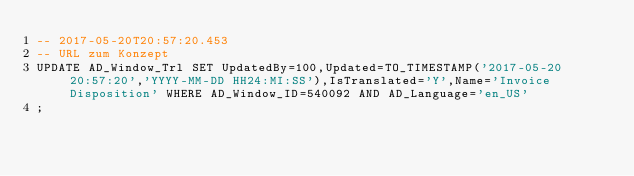<code> <loc_0><loc_0><loc_500><loc_500><_SQL_>-- 2017-05-20T20:57:20.453
-- URL zum Konzept
UPDATE AD_Window_Trl SET UpdatedBy=100,Updated=TO_TIMESTAMP('2017-05-20 20:57:20','YYYY-MM-DD HH24:MI:SS'),IsTranslated='Y',Name='Invoice Disposition' WHERE AD_Window_ID=540092 AND AD_Language='en_US'
;</code> 